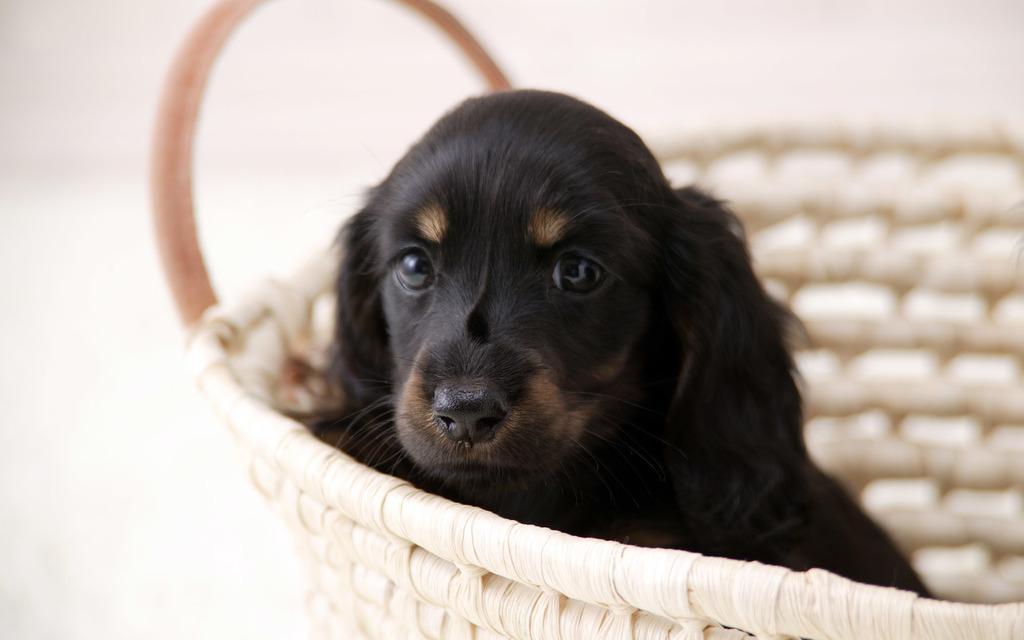Please provide a concise description of this image. In this image we can see dog in basket. 